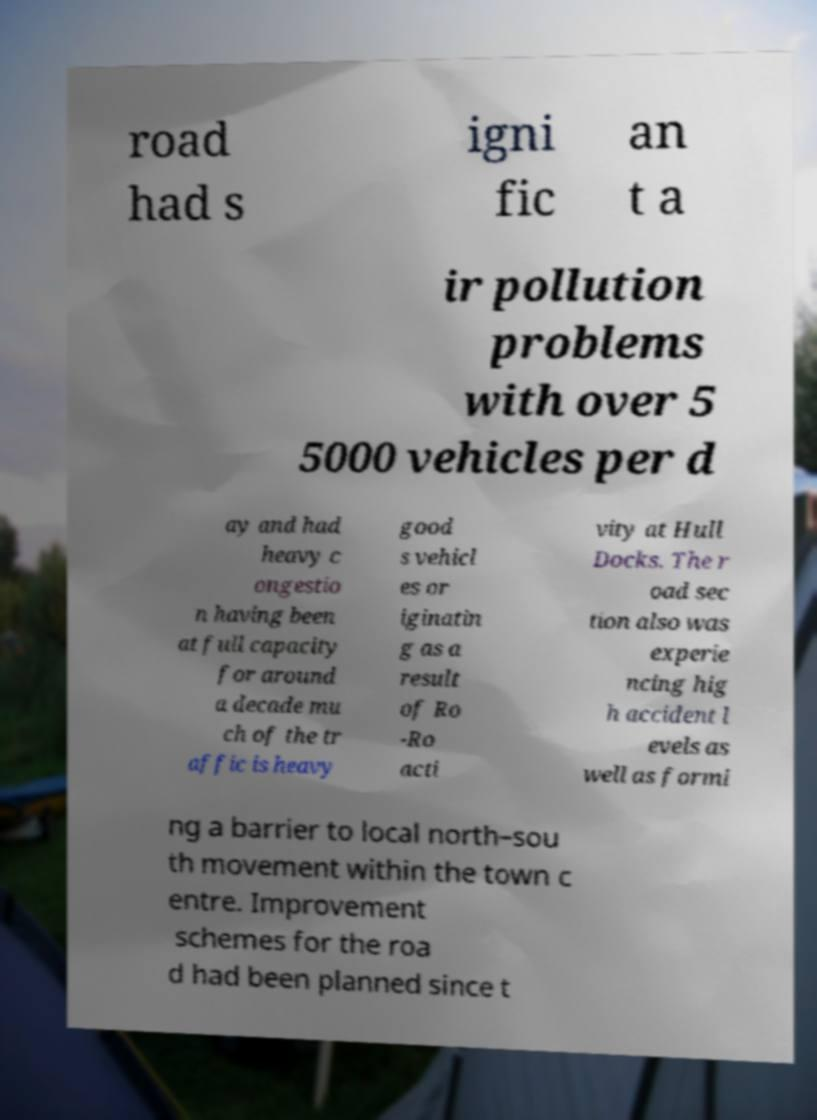Can you read and provide the text displayed in the image?This photo seems to have some interesting text. Can you extract and type it out for me? road had s igni fic an t a ir pollution problems with over 5 5000 vehicles per d ay and had heavy c ongestio n having been at full capacity for around a decade mu ch of the tr affic is heavy good s vehicl es or iginatin g as a result of Ro -Ro acti vity at Hull Docks. The r oad sec tion also was experie ncing hig h accident l evels as well as formi ng a barrier to local north–sou th movement within the town c entre. Improvement schemes for the roa d had been planned since t 